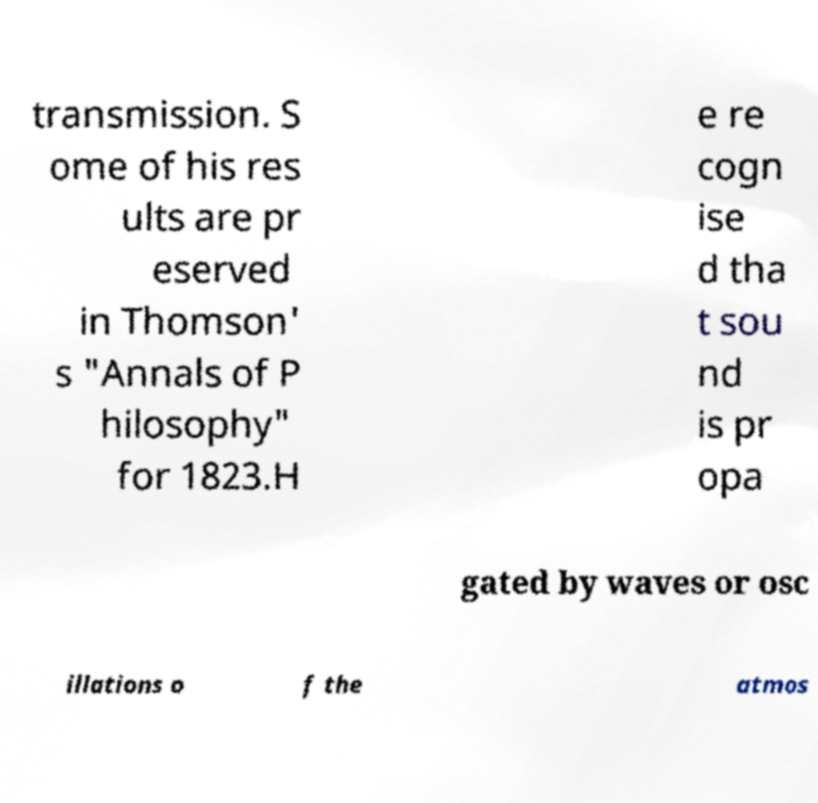What messages or text are displayed in this image? I need them in a readable, typed format. transmission. S ome of his res ults are pr eserved in Thomson' s "Annals of P hilosophy" for 1823.H e re cogn ise d tha t sou nd is pr opa gated by waves or osc illations o f the atmos 